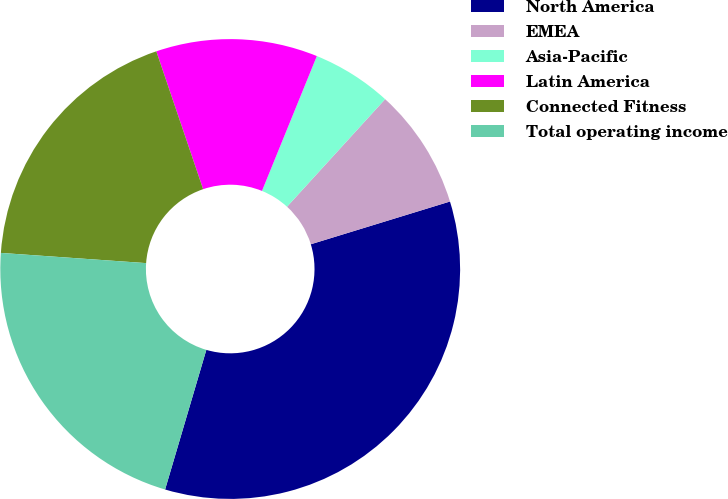Convert chart to OTSL. <chart><loc_0><loc_0><loc_500><loc_500><pie_chart><fcel>North America<fcel>EMEA<fcel>Asia-Pacific<fcel>Latin America<fcel>Connected Fitness<fcel>Total operating income<nl><fcel>34.32%<fcel>8.49%<fcel>5.62%<fcel>11.36%<fcel>18.68%<fcel>21.55%<nl></chart> 